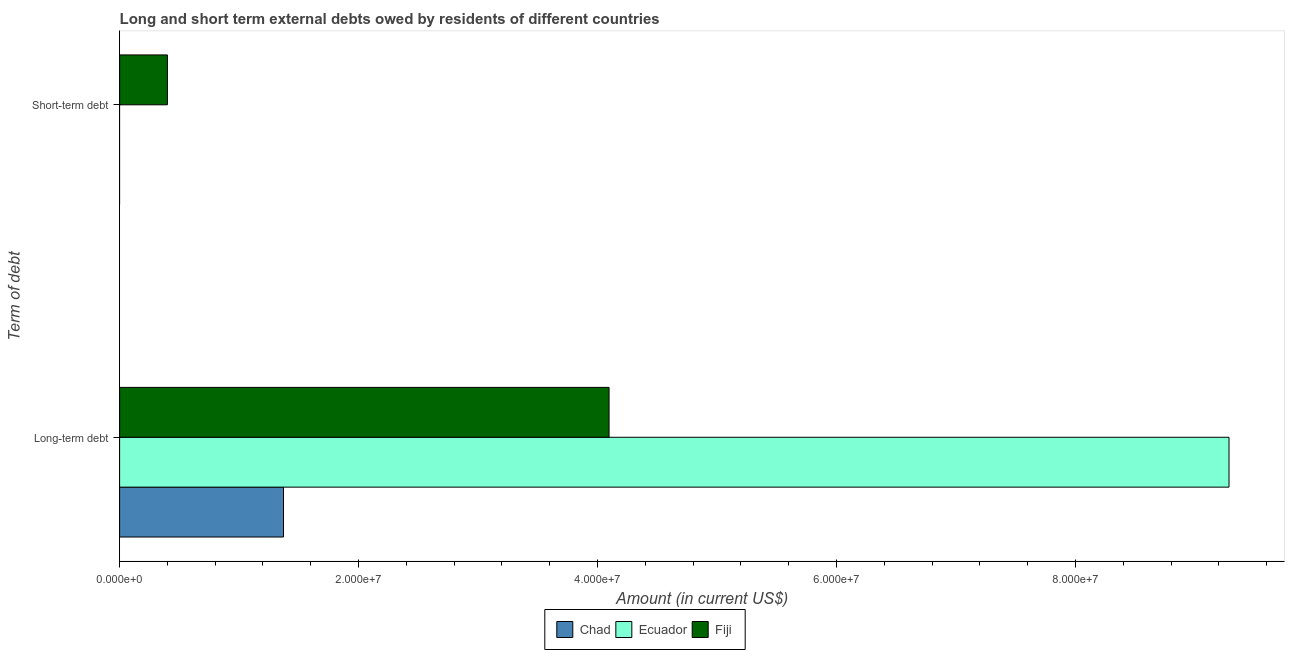How many different coloured bars are there?
Your response must be concise. 3. How many bars are there on the 2nd tick from the top?
Make the answer very short. 3. How many bars are there on the 1st tick from the bottom?
Provide a succinct answer. 3. What is the label of the 2nd group of bars from the top?
Keep it short and to the point. Long-term debt. What is the long-term debts owed by residents in Fiji?
Keep it short and to the point. 4.10e+07. Across all countries, what is the maximum short-term debts owed by residents?
Keep it short and to the point. 4.00e+06. Across all countries, what is the minimum long-term debts owed by residents?
Provide a succinct answer. 1.37e+07. In which country was the short-term debts owed by residents maximum?
Keep it short and to the point. Fiji. What is the total short-term debts owed by residents in the graph?
Offer a very short reply. 4.00e+06. What is the difference between the long-term debts owed by residents in Ecuador and that in Fiji?
Offer a terse response. 5.19e+07. What is the difference between the short-term debts owed by residents in Ecuador and the long-term debts owed by residents in Chad?
Make the answer very short. -1.37e+07. What is the average short-term debts owed by residents per country?
Your answer should be very brief. 1.33e+06. What is the difference between the short-term debts owed by residents and long-term debts owed by residents in Fiji?
Your answer should be very brief. -3.70e+07. What is the ratio of the long-term debts owed by residents in Ecuador to that in Chad?
Provide a short and direct response. 6.77. Is the long-term debts owed by residents in Ecuador less than that in Fiji?
Offer a very short reply. No. In how many countries, is the long-term debts owed by residents greater than the average long-term debts owed by residents taken over all countries?
Provide a short and direct response. 1. Are all the bars in the graph horizontal?
Provide a short and direct response. Yes. What is the difference between two consecutive major ticks on the X-axis?
Offer a very short reply. 2.00e+07. Are the values on the major ticks of X-axis written in scientific E-notation?
Your answer should be very brief. Yes. How are the legend labels stacked?
Your answer should be compact. Horizontal. What is the title of the graph?
Your answer should be very brief. Long and short term external debts owed by residents of different countries. What is the label or title of the Y-axis?
Give a very brief answer. Term of debt. What is the Amount (in current US$) of Chad in Long-term debt?
Your answer should be very brief. 1.37e+07. What is the Amount (in current US$) of Ecuador in Long-term debt?
Ensure brevity in your answer.  9.29e+07. What is the Amount (in current US$) in Fiji in Long-term debt?
Offer a terse response. 4.10e+07. What is the Amount (in current US$) in Chad in Short-term debt?
Your answer should be very brief. 0. What is the Amount (in current US$) in Fiji in Short-term debt?
Give a very brief answer. 4.00e+06. Across all Term of debt, what is the maximum Amount (in current US$) in Chad?
Keep it short and to the point. 1.37e+07. Across all Term of debt, what is the maximum Amount (in current US$) of Ecuador?
Provide a short and direct response. 9.29e+07. Across all Term of debt, what is the maximum Amount (in current US$) in Fiji?
Give a very brief answer. 4.10e+07. Across all Term of debt, what is the minimum Amount (in current US$) of Chad?
Provide a short and direct response. 0. Across all Term of debt, what is the minimum Amount (in current US$) of Ecuador?
Make the answer very short. 0. What is the total Amount (in current US$) of Chad in the graph?
Give a very brief answer. 1.37e+07. What is the total Amount (in current US$) in Ecuador in the graph?
Provide a short and direct response. 9.29e+07. What is the total Amount (in current US$) of Fiji in the graph?
Give a very brief answer. 4.50e+07. What is the difference between the Amount (in current US$) of Fiji in Long-term debt and that in Short-term debt?
Your answer should be compact. 3.70e+07. What is the difference between the Amount (in current US$) in Chad in Long-term debt and the Amount (in current US$) in Fiji in Short-term debt?
Offer a very short reply. 9.72e+06. What is the difference between the Amount (in current US$) in Ecuador in Long-term debt and the Amount (in current US$) in Fiji in Short-term debt?
Provide a succinct answer. 8.89e+07. What is the average Amount (in current US$) in Chad per Term of debt?
Make the answer very short. 6.86e+06. What is the average Amount (in current US$) of Ecuador per Term of debt?
Offer a very short reply. 4.64e+07. What is the average Amount (in current US$) of Fiji per Term of debt?
Ensure brevity in your answer.  2.25e+07. What is the difference between the Amount (in current US$) in Chad and Amount (in current US$) in Ecuador in Long-term debt?
Your answer should be compact. -7.91e+07. What is the difference between the Amount (in current US$) of Chad and Amount (in current US$) of Fiji in Long-term debt?
Offer a terse response. -2.72e+07. What is the difference between the Amount (in current US$) in Ecuador and Amount (in current US$) in Fiji in Long-term debt?
Make the answer very short. 5.19e+07. What is the ratio of the Amount (in current US$) of Fiji in Long-term debt to that in Short-term debt?
Give a very brief answer. 10.24. What is the difference between the highest and the second highest Amount (in current US$) in Fiji?
Your response must be concise. 3.70e+07. What is the difference between the highest and the lowest Amount (in current US$) of Chad?
Provide a short and direct response. 1.37e+07. What is the difference between the highest and the lowest Amount (in current US$) of Ecuador?
Your response must be concise. 9.29e+07. What is the difference between the highest and the lowest Amount (in current US$) in Fiji?
Your answer should be compact. 3.70e+07. 